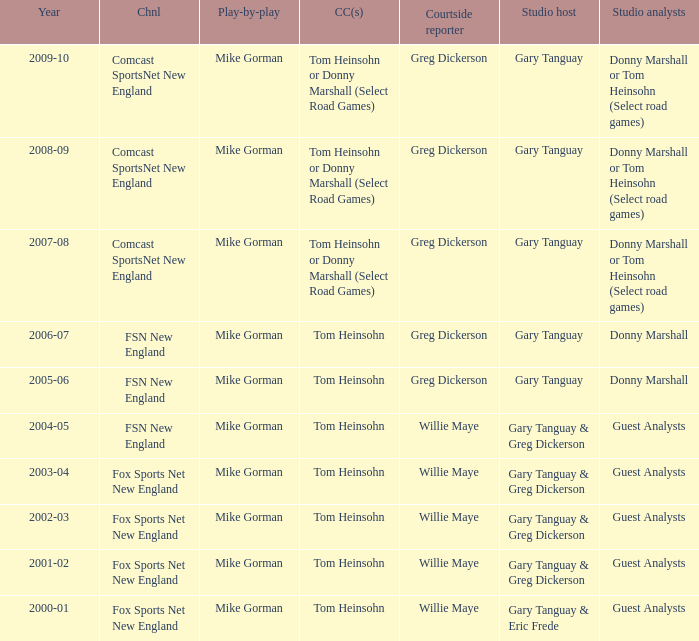WHich Studio host has a Year of 2003-04? Gary Tanguay & Greg Dickerson. 